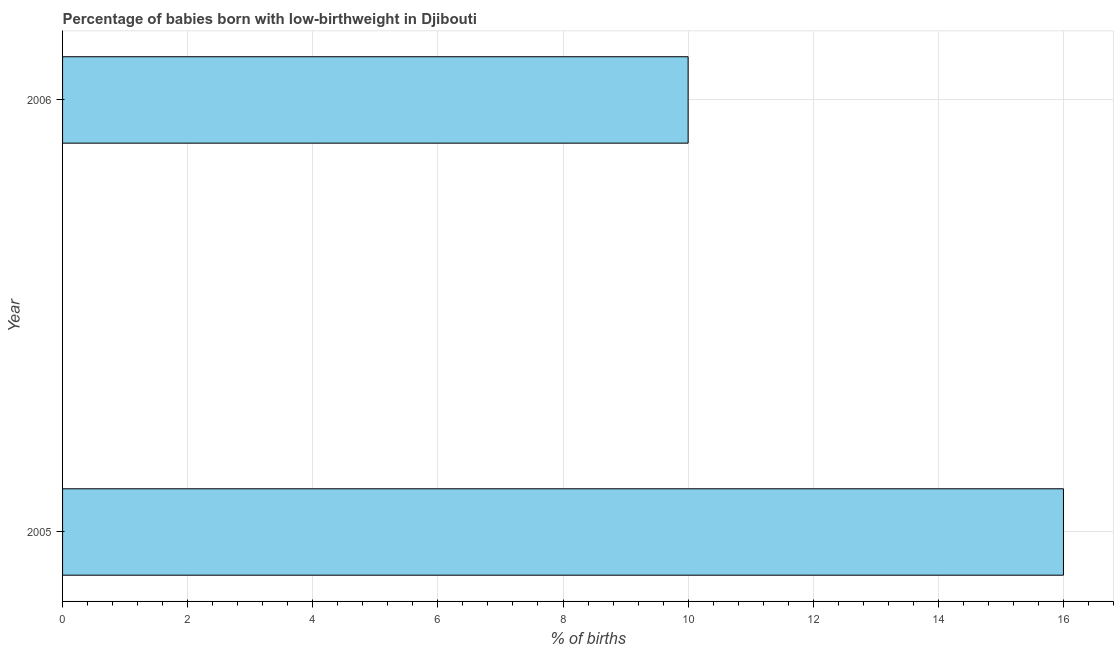What is the title of the graph?
Your answer should be very brief. Percentage of babies born with low-birthweight in Djibouti. What is the label or title of the X-axis?
Give a very brief answer. % of births. What is the percentage of babies who were born with low-birthweight in 2006?
Provide a short and direct response. 10. Across all years, what is the minimum percentage of babies who were born with low-birthweight?
Make the answer very short. 10. What is the sum of the percentage of babies who were born with low-birthweight?
Provide a short and direct response. 26. What is the difference between the percentage of babies who were born with low-birthweight in 2005 and 2006?
Your response must be concise. 6. Is the percentage of babies who were born with low-birthweight in 2005 less than that in 2006?
Ensure brevity in your answer.  No. How many bars are there?
Provide a succinct answer. 2. Are all the bars in the graph horizontal?
Provide a succinct answer. Yes. What is the difference between two consecutive major ticks on the X-axis?
Keep it short and to the point. 2. What is the % of births of 2005?
Offer a terse response. 16. What is the % of births of 2006?
Provide a succinct answer. 10. What is the ratio of the % of births in 2005 to that in 2006?
Make the answer very short. 1.6. 